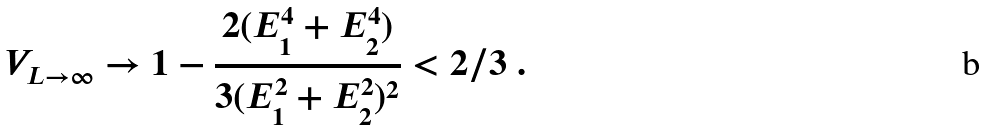Convert formula to latex. <formula><loc_0><loc_0><loc_500><loc_500>V _ { L \rightarrow \infty } \rightarrow 1 - \frac { 2 ( E _ { 1 } ^ { 4 } + E _ { 2 } ^ { 4 } ) } { 3 ( E _ { 1 } ^ { 2 } + E _ { 2 } ^ { 2 } ) ^ { 2 } } < 2 / 3 \ .</formula> 